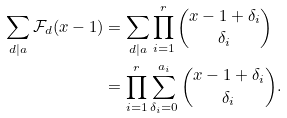<formula> <loc_0><loc_0><loc_500><loc_500>\sum _ { d | a } \mathcal { F } _ { d } ( x - 1 ) & = \sum _ { d | a } \prod _ { i = 1 } ^ { r } \binom { x - 1 + \delta _ { i } } { \delta _ { i } } \\ & = \prod _ { i = 1 } ^ { r } \sum _ { \delta _ { i } = 0 } ^ { a _ { i } } \binom { x - 1 + \delta _ { i } } { \delta _ { i } } .</formula> 